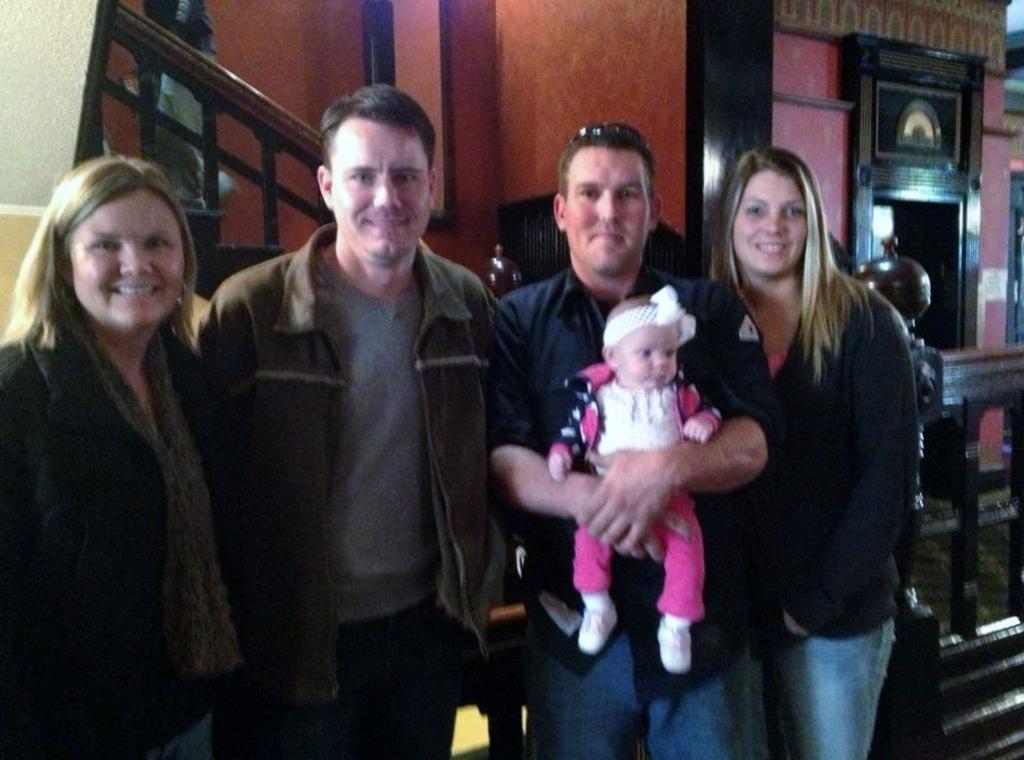Can you describe this image briefly? Here we can see four people standing and smiling. This man is holding a baby. A person is on the stairs.  